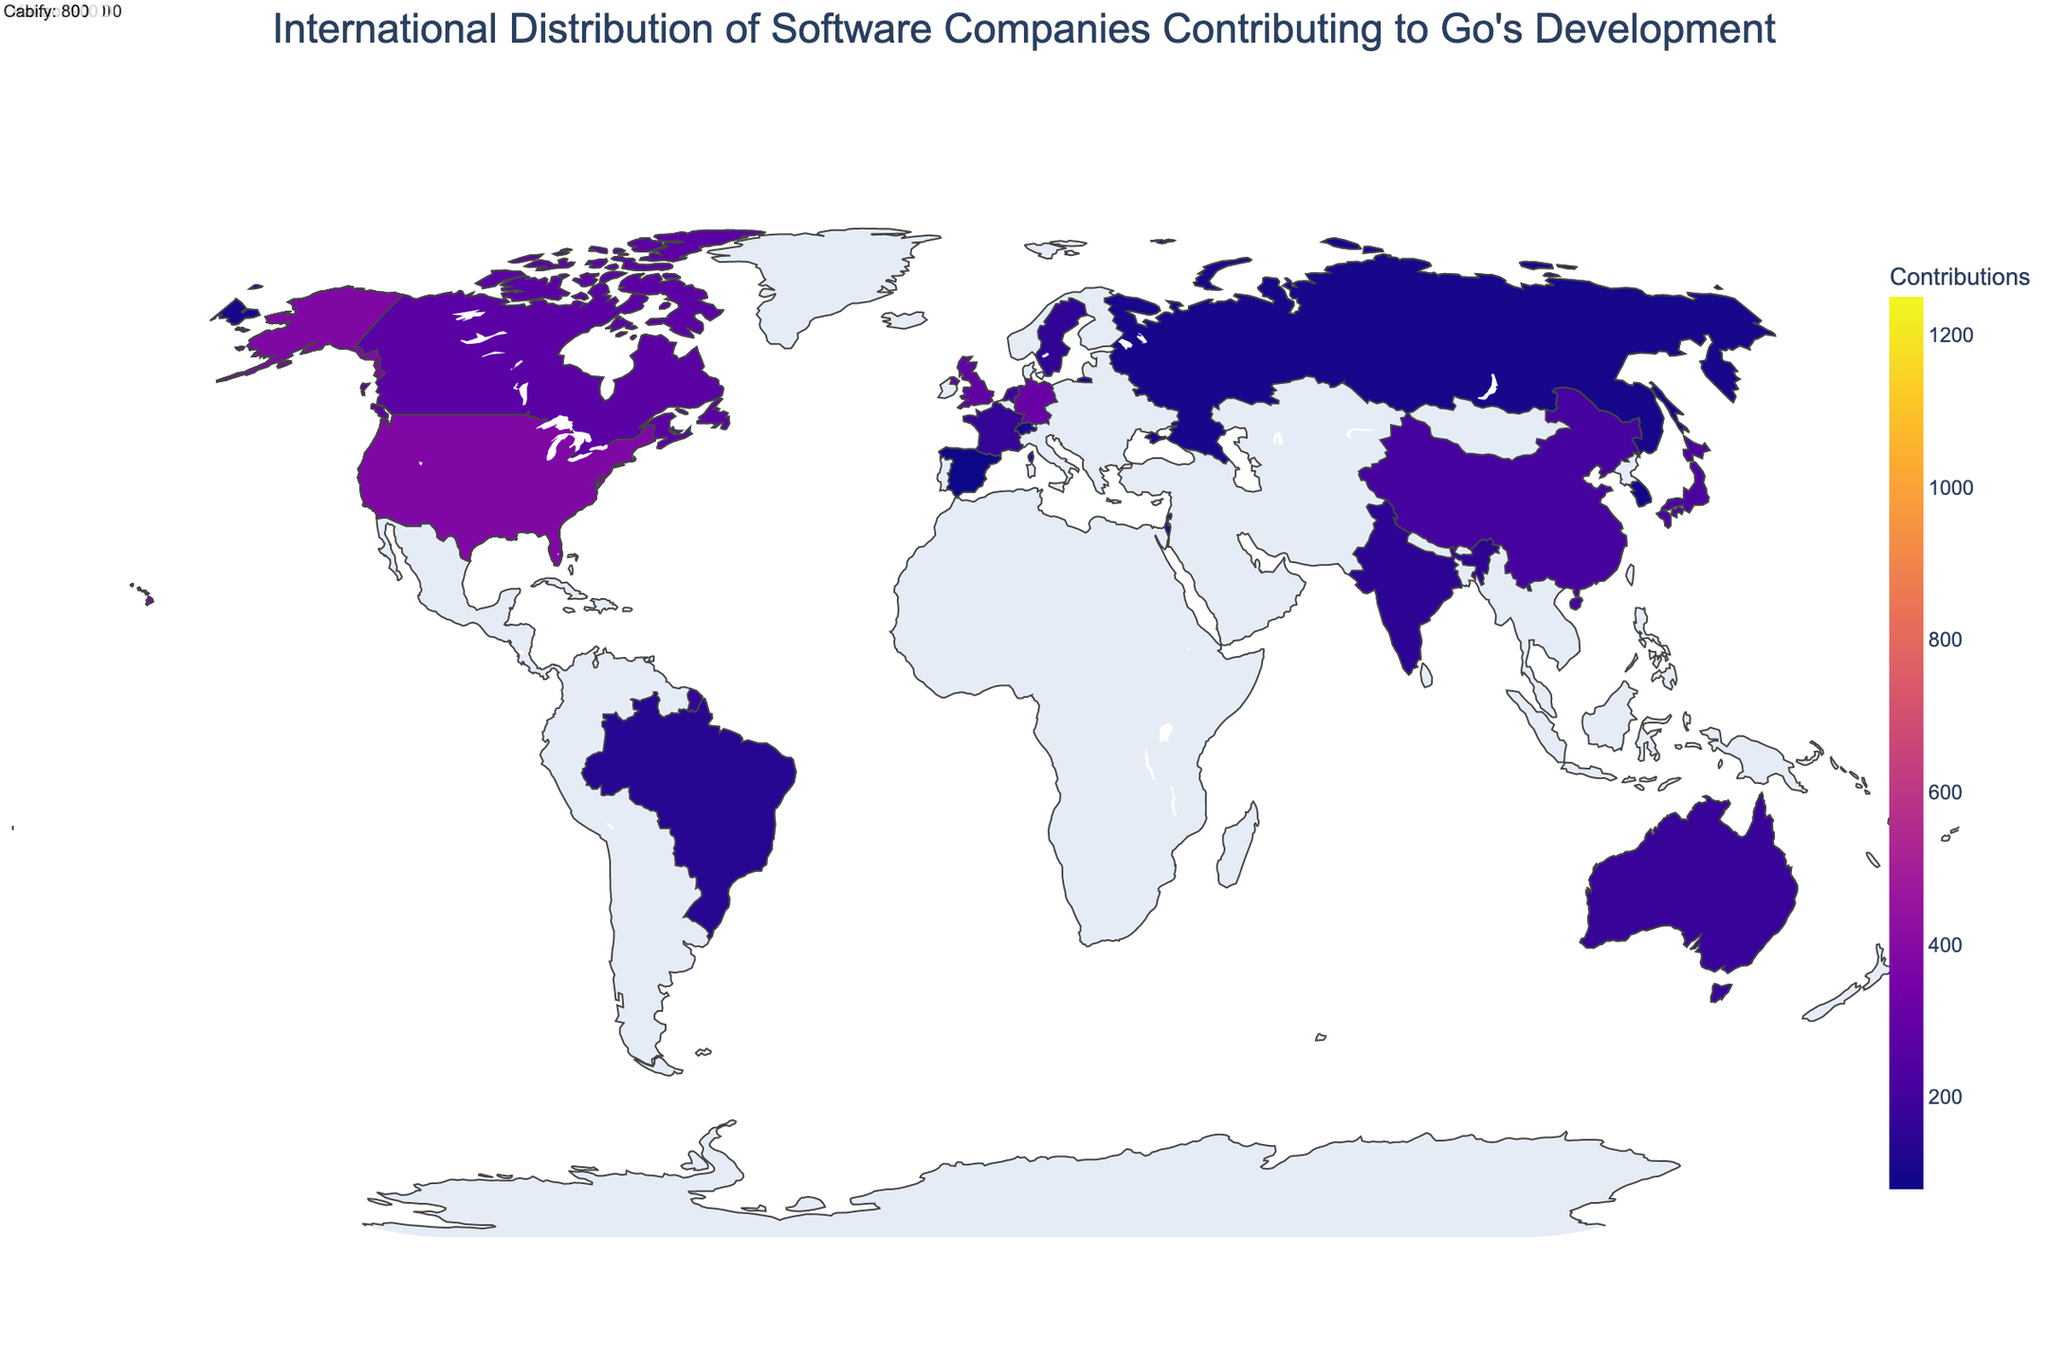What's the title of the figure? The title of the figure is centrally aligned at the top and gives an overview of the geographical distribution of contributions to Go's development by software companies.
Answer: International Distribution of Software Companies Contributing to Go's Development How many companies from the United States are contributing? To determine the number of companies from the United States, look at the data and count the number of distinct companies listed under "United States".
Answer: 3 Which country has the highest number of contributions? Look at the color intensity on the plot and hover to see the contributions; the country with the highest number of contributions will have the most intense color. The United States has the highest number of contributions.
Answer: United States What is the total number of contributions from companies not in the United States? Sum the contributions from all countries excluding the United States (1250 + 420 + 380).
Answer: 3120 Which company in Germany is actively contributing to Go's development and how many contributions do they have? Hover over Germany in the geographic plot to get the company name and their number of contributions; it's SAP in Germany.
Answer: SAP, 310 Compare the contributions of companies in the United States and China. Add the contributions from all companies in the United States and compare with the contributions from China. United States: 1250 + 420 + 380 = 2050, China: 210. Therefore, the United States has 2050 contributions which is significantly higher than China’s 210 contributions.
Answer: United States: 2050, China: 210 Which region (continent) has the most total contributions? Normalize the data based on continental regions, sum contributions within each region, and compare total contributions to see which region has the highest.
Answer: North America How does the contribution from the company in Spain compare to the company in Switzerland? Look at the contributions from Spain (Cabify) and Switzerland (Roche), then compare them directly. Contributions from Spain: 80, Contributions from Switzerland: 110. Therefore, Switzerland has more contributions.
Answer: Spain: 80, Switzerland: 110 Identify the company and contributions from Japan. Hover over Japan in the geographic map to get the name of the company and the number of their contributions. It's Mercari with 230 contributions.
Answer: Mercari, 230 